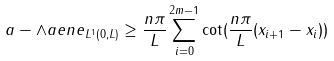<formula> <loc_0><loc_0><loc_500><loc_500>\| a - \land a e n e \| _ { L ^ { 1 } ( 0 , L ) } \geq \frac { n \pi } { L } \sum _ { i = 0 } ^ { 2 m - 1 } \cot ( \frac { n \pi } { L } ( x _ { i + 1 } - x _ { i } ) )</formula> 